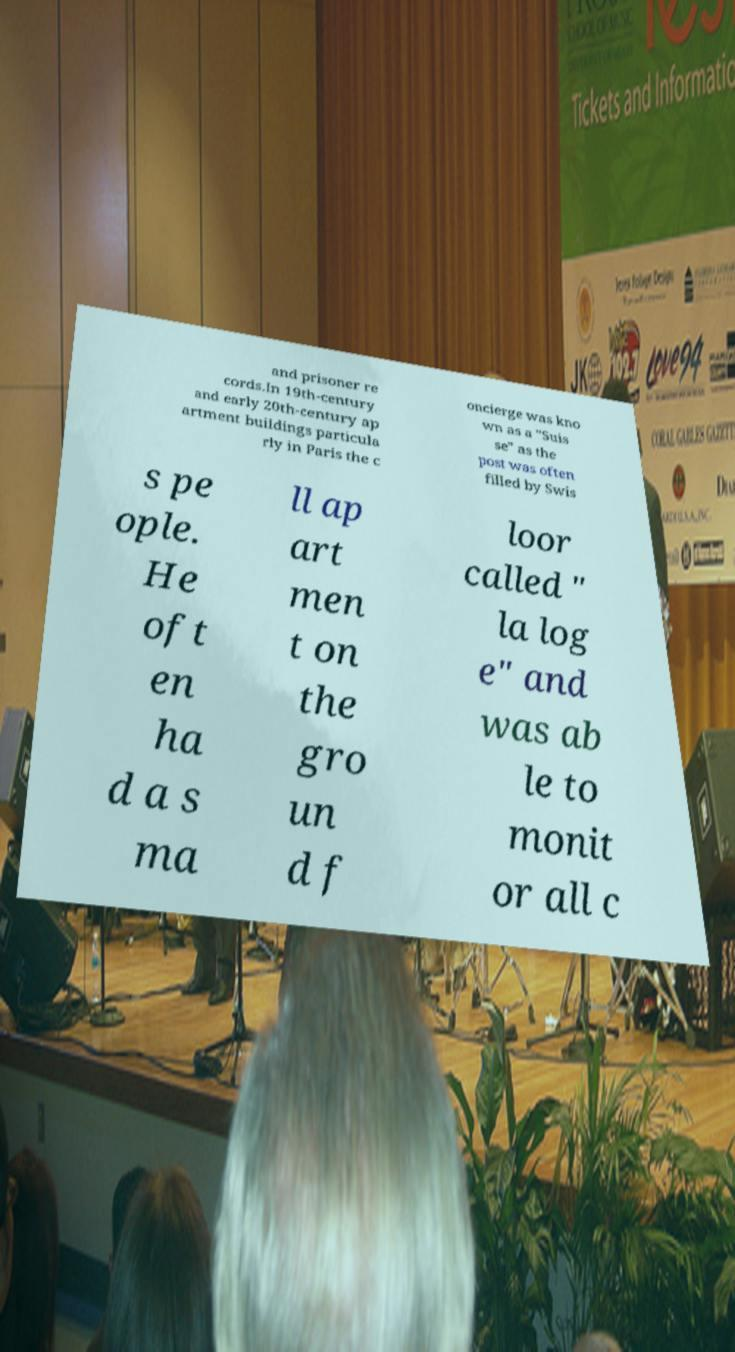Can you read and provide the text displayed in the image?This photo seems to have some interesting text. Can you extract and type it out for me? and prisoner re cords.In 19th-century and early 20th-century ap artment buildings particula rly in Paris the c oncierge was kno wn as a "Suis se" as the post was often filled by Swis s pe ople. He oft en ha d a s ma ll ap art men t on the gro un d f loor called " la log e" and was ab le to monit or all c 